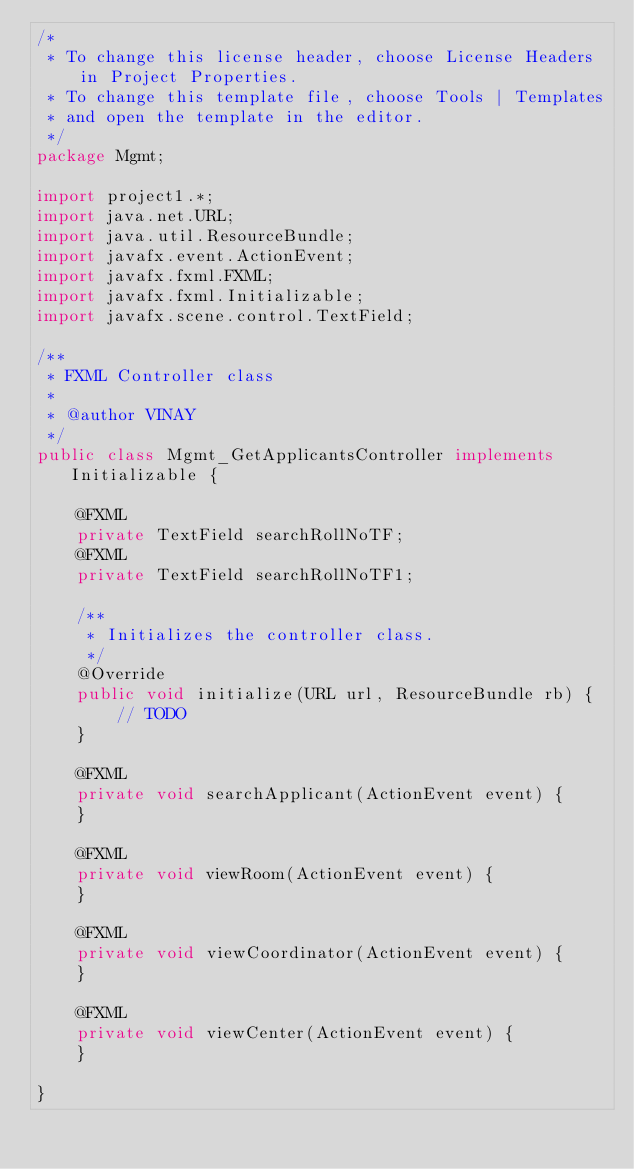Convert code to text. <code><loc_0><loc_0><loc_500><loc_500><_Java_>/*
 * To change this license header, choose License Headers in Project Properties.
 * To change this template file, choose Tools | Templates
 * and open the template in the editor.
 */
package Mgmt;

import project1.*;
import java.net.URL;
import java.util.ResourceBundle;
import javafx.event.ActionEvent;
import javafx.fxml.FXML;
import javafx.fxml.Initializable;
import javafx.scene.control.TextField;

/**
 * FXML Controller class
 *
 * @author VINAY
 */
public class Mgmt_GetApplicantsController implements Initializable {

    @FXML
    private TextField searchRollNoTF;
    @FXML
    private TextField searchRollNoTF1;

    /**
     * Initializes the controller class.
     */
    @Override
    public void initialize(URL url, ResourceBundle rb) {
        // TODO
    }    

    @FXML
    private void searchApplicant(ActionEvent event) {
    }

    @FXML
    private void viewRoom(ActionEvent event) {
    }

    @FXML
    private void viewCoordinator(ActionEvent event) {
    }

    @FXML
    private void viewCenter(ActionEvent event) {
    }
    
}
</code> 